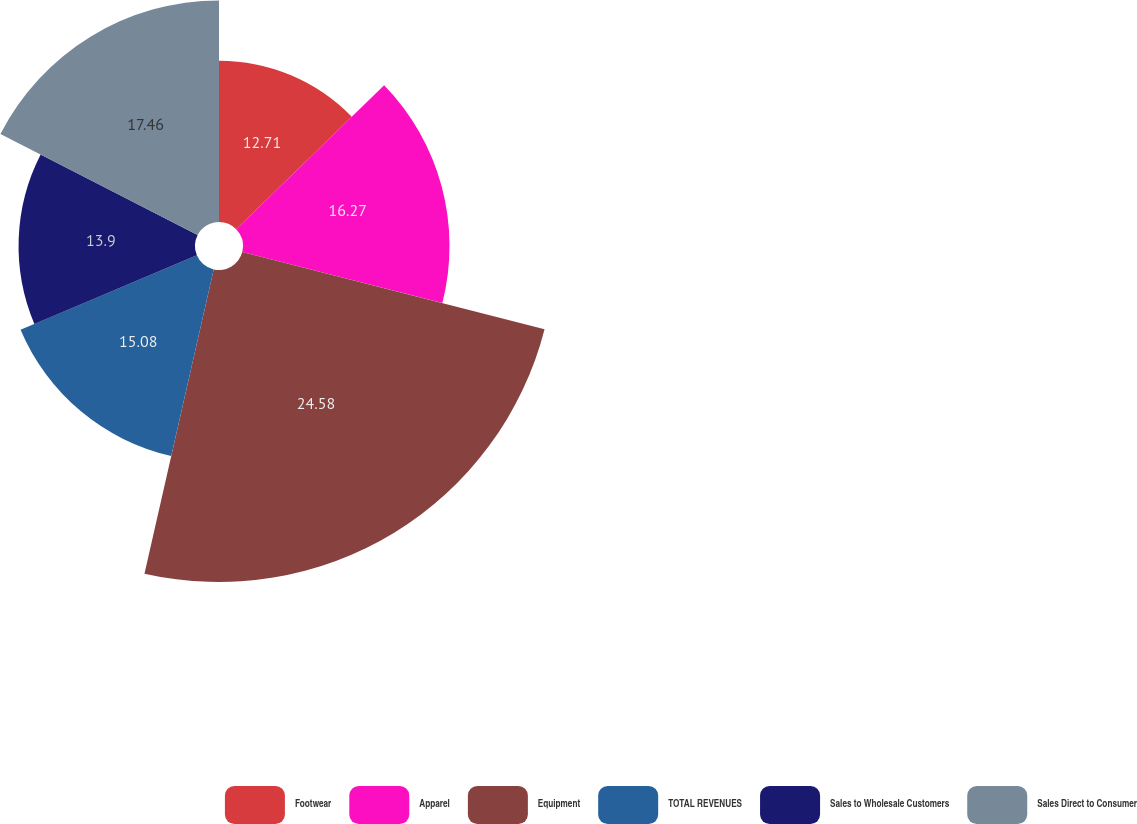Convert chart. <chart><loc_0><loc_0><loc_500><loc_500><pie_chart><fcel>Footwear<fcel>Apparel<fcel>Equipment<fcel>TOTAL REVENUES<fcel>Sales to Wholesale Customers<fcel>Sales Direct to Consumer<nl><fcel>12.71%<fcel>16.27%<fcel>24.58%<fcel>15.08%<fcel>13.9%<fcel>17.46%<nl></chart> 